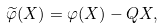Convert formula to latex. <formula><loc_0><loc_0><loc_500><loc_500>\widetilde { \varphi } ( X ) = \varphi ( X ) - Q X ,</formula> 